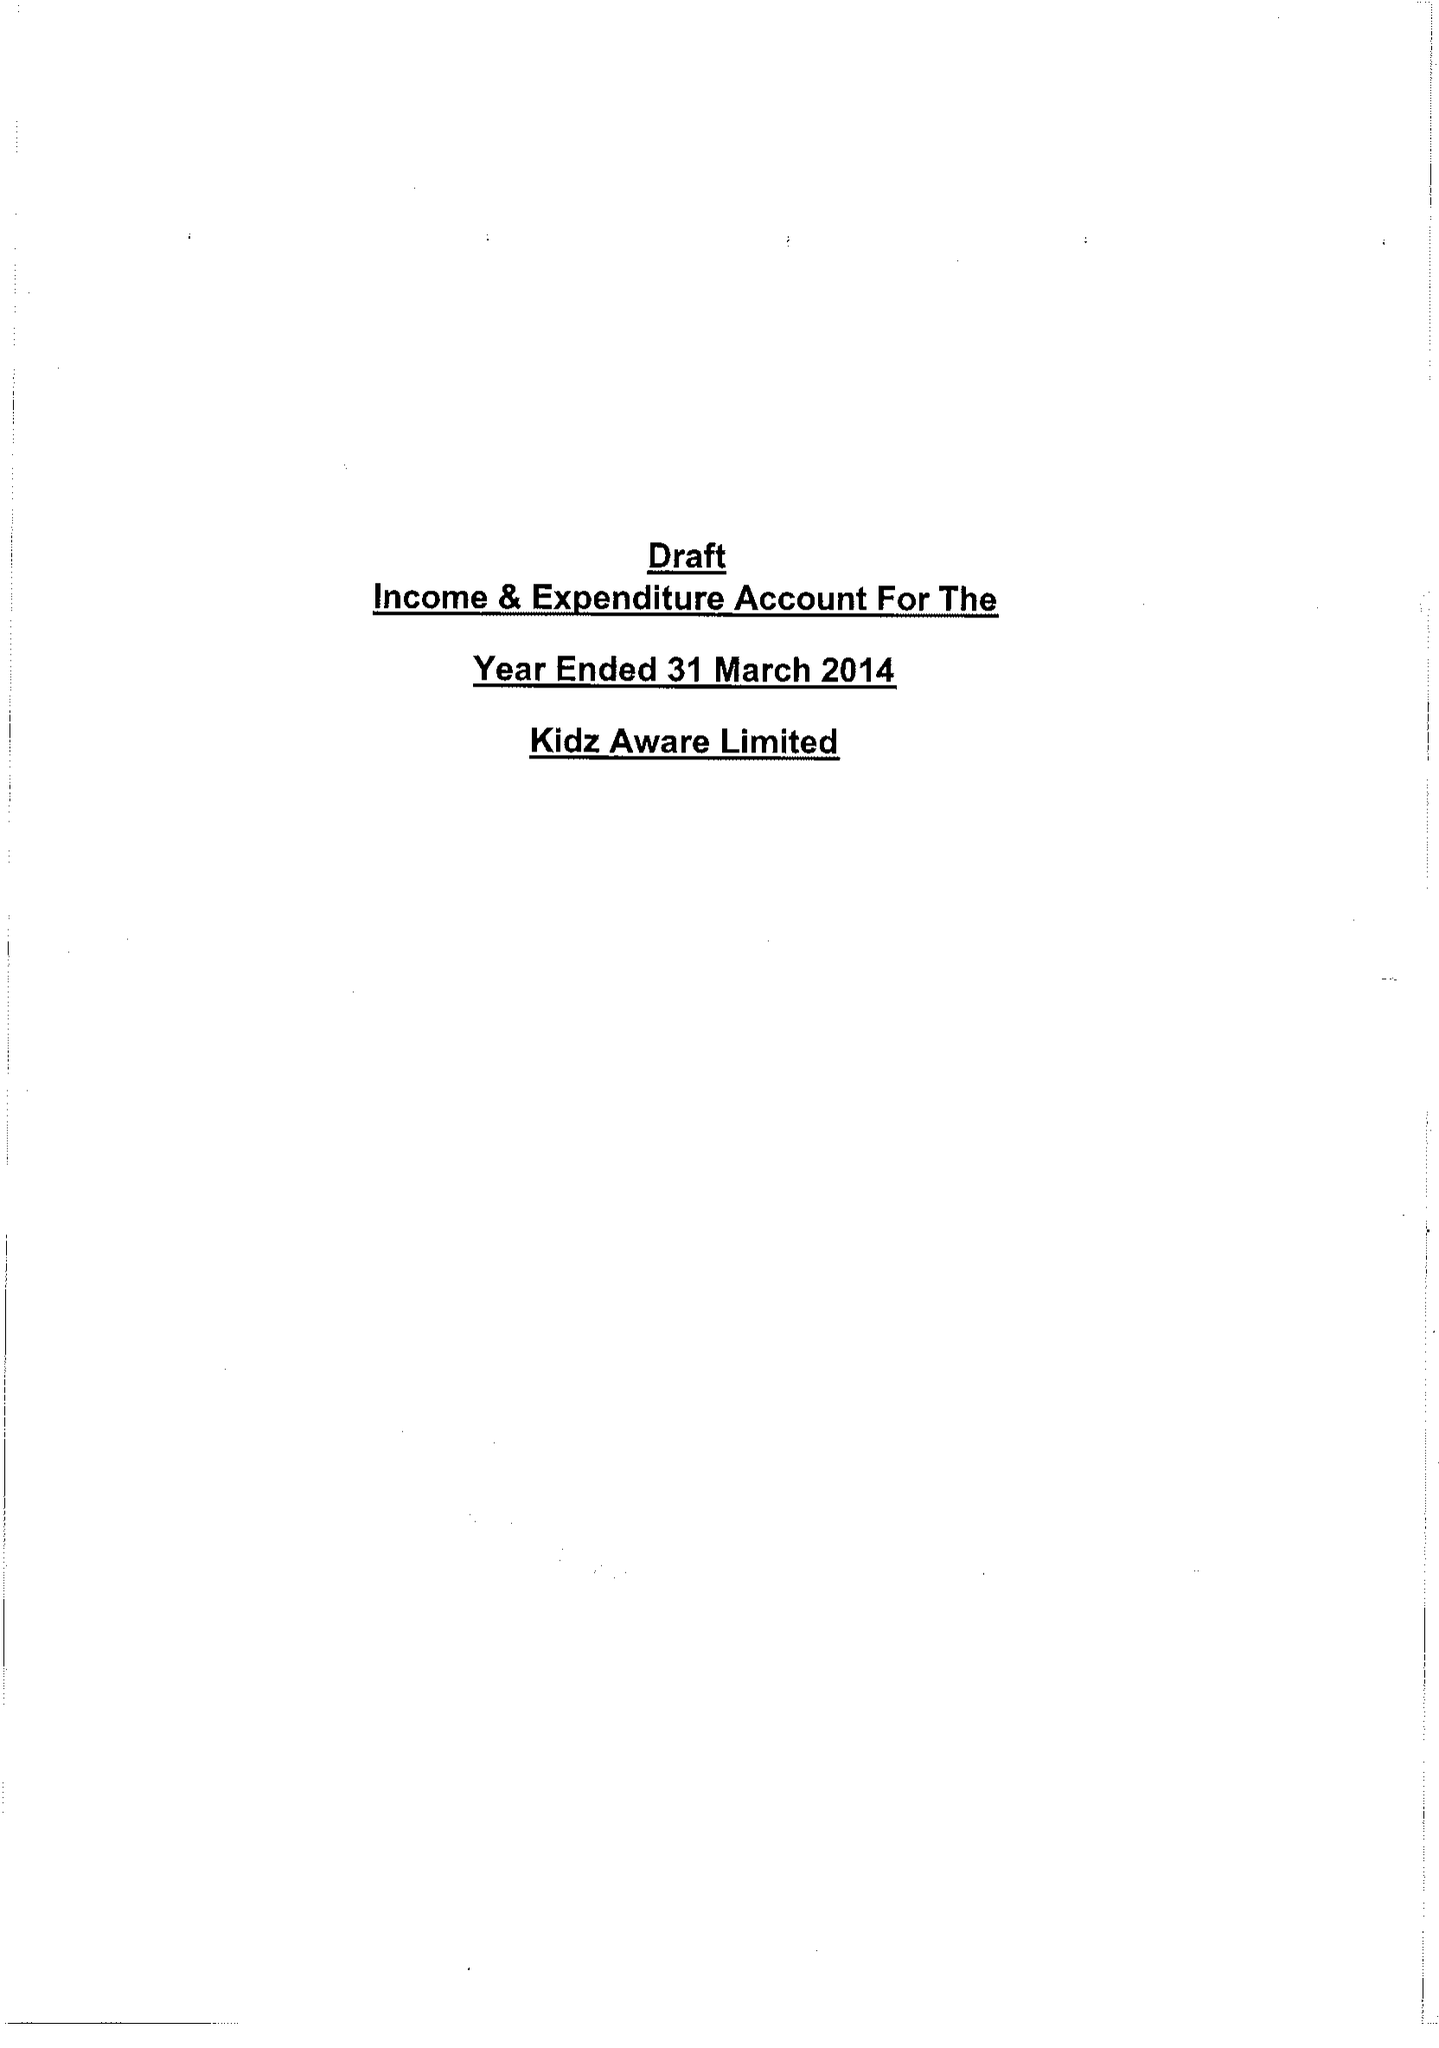What is the value for the report_date?
Answer the question using a single word or phrase. 2014-04-30 